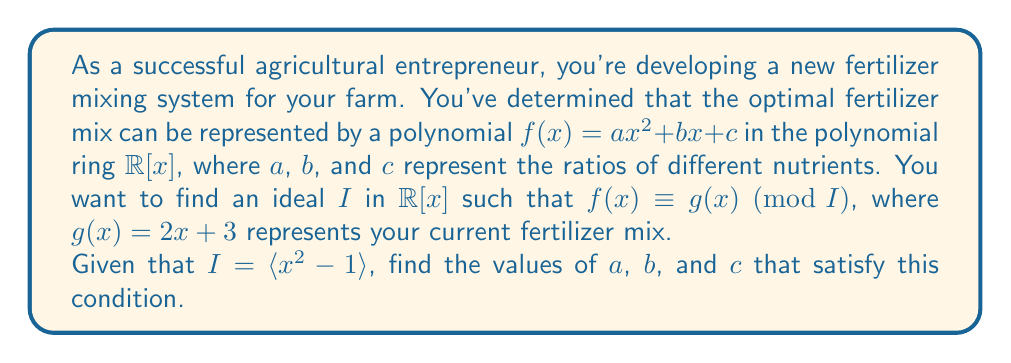Can you answer this question? To solve this problem, we'll use the properties of polynomial rings and ideal theory:

1) The ideal $I = \langle x^2 - 1 \rangle$ contains all polynomials that are divisible by $x^2 - 1$. This means that in the quotient ring $\mathbb{R}[x]/I$, we have $x^2 \equiv 1 \pmod{I}$.

2) We want $f(x) \equiv g(x) \pmod{I}$, which means:

   $ax^2 + bx + c \equiv 2x + 3 \pmod{I}$

3) Using the property from step 1, we can replace $x^2$ with 1:

   $a(1) + bx + c \equiv 2x + 3 \pmod{I}$

4) Simplifying:

   $a + bx + c \equiv 2x + 3 \pmod{I}$

5) For two polynomials to be equivalent modulo $I$, their coefficients must be equal. So:

   $b = 2$
   $a + c = 3$

6) We now have two equations and three unknowns. To fully determine the system, we can choose any value for $a$. Let's choose $a = 1$ for simplicity.

7) If $a = 1$, then from $a + c = 3$, we get:

   $1 + c = 3$
   $c = 2$

Therefore, one solution that satisfies the conditions is $a = 1$, $b = 2$, and $c = 2$.
Answer: $a = 1$, $b = 2$, $c = 2$ 